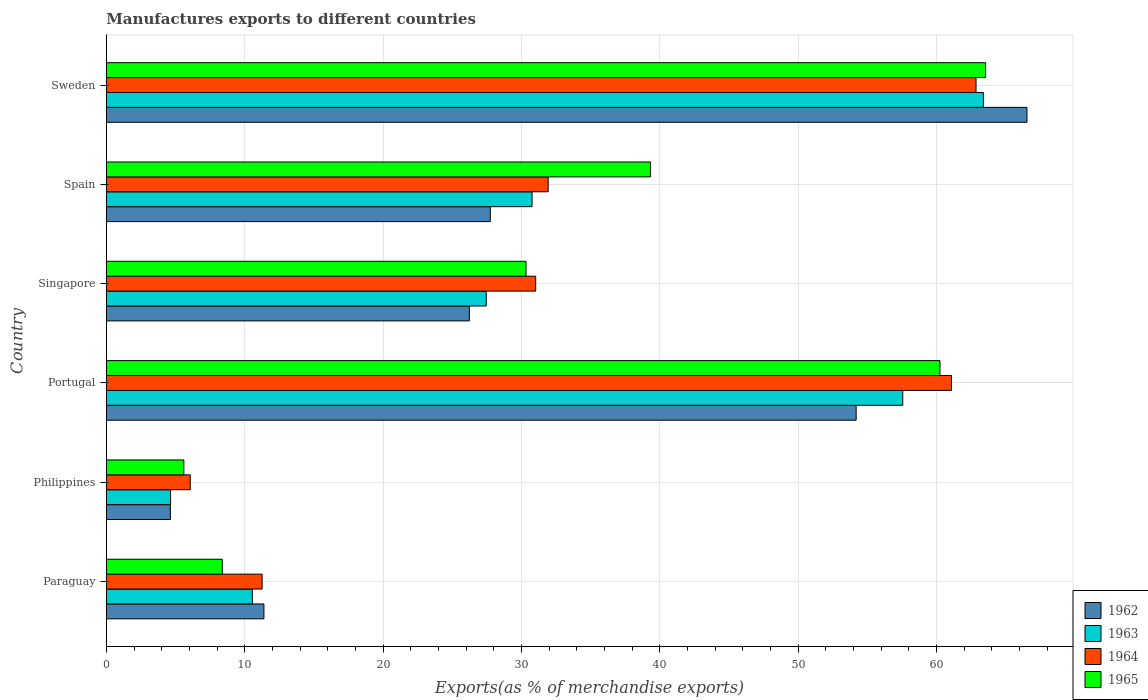How many different coloured bars are there?
Provide a short and direct response. 4. Are the number of bars per tick equal to the number of legend labels?
Offer a terse response. Yes. Are the number of bars on each tick of the Y-axis equal?
Make the answer very short. Yes. How many bars are there on the 1st tick from the bottom?
Make the answer very short. 4. What is the label of the 3rd group of bars from the top?
Provide a succinct answer. Singapore. What is the percentage of exports to different countries in 1965 in Sweden?
Offer a very short reply. 63.55. Across all countries, what is the maximum percentage of exports to different countries in 1964?
Give a very brief answer. 62.86. Across all countries, what is the minimum percentage of exports to different countries in 1964?
Offer a terse response. 6.07. What is the total percentage of exports to different countries in 1962 in the graph?
Keep it short and to the point. 190.73. What is the difference between the percentage of exports to different countries in 1963 in Portugal and that in Singapore?
Keep it short and to the point. 30.1. What is the difference between the percentage of exports to different countries in 1965 in Portugal and the percentage of exports to different countries in 1963 in Paraguay?
Make the answer very short. 49.7. What is the average percentage of exports to different countries in 1964 per country?
Provide a succinct answer. 34.04. What is the difference between the percentage of exports to different countries in 1964 and percentage of exports to different countries in 1965 in Portugal?
Keep it short and to the point. 0.83. What is the ratio of the percentage of exports to different countries in 1964 in Philippines to that in Sweden?
Provide a succinct answer. 0.1. Is the percentage of exports to different countries in 1963 in Singapore less than that in Spain?
Ensure brevity in your answer.  Yes. Is the difference between the percentage of exports to different countries in 1964 in Paraguay and Sweden greater than the difference between the percentage of exports to different countries in 1965 in Paraguay and Sweden?
Your response must be concise. Yes. What is the difference between the highest and the second highest percentage of exports to different countries in 1963?
Your response must be concise. 5.83. What is the difference between the highest and the lowest percentage of exports to different countries in 1963?
Ensure brevity in your answer.  58.74. Is it the case that in every country, the sum of the percentage of exports to different countries in 1962 and percentage of exports to different countries in 1963 is greater than the sum of percentage of exports to different countries in 1964 and percentage of exports to different countries in 1965?
Your answer should be compact. No. What does the 4th bar from the top in Spain represents?
Offer a very short reply. 1962. How many bars are there?
Make the answer very short. 24. Are all the bars in the graph horizontal?
Give a very brief answer. Yes. How many countries are there in the graph?
Your answer should be compact. 6. Does the graph contain any zero values?
Offer a terse response. No. What is the title of the graph?
Ensure brevity in your answer.  Manufactures exports to different countries. What is the label or title of the X-axis?
Offer a very short reply. Exports(as % of merchandise exports). What is the Exports(as % of merchandise exports) in 1962 in Paraguay?
Keep it short and to the point. 11.39. What is the Exports(as % of merchandise exports) of 1963 in Paraguay?
Keep it short and to the point. 10.55. What is the Exports(as % of merchandise exports) in 1964 in Paraguay?
Ensure brevity in your answer.  11.26. What is the Exports(as % of merchandise exports) of 1965 in Paraguay?
Keep it short and to the point. 8.38. What is the Exports(as % of merchandise exports) of 1962 in Philippines?
Provide a short and direct response. 4.63. What is the Exports(as % of merchandise exports) in 1963 in Philippines?
Your response must be concise. 4.64. What is the Exports(as % of merchandise exports) in 1964 in Philippines?
Your response must be concise. 6.07. What is the Exports(as % of merchandise exports) in 1965 in Philippines?
Your answer should be very brief. 5.6. What is the Exports(as % of merchandise exports) in 1962 in Portugal?
Offer a terse response. 54.19. What is the Exports(as % of merchandise exports) of 1963 in Portugal?
Give a very brief answer. 57.56. What is the Exports(as % of merchandise exports) in 1964 in Portugal?
Make the answer very short. 61.08. What is the Exports(as % of merchandise exports) in 1965 in Portugal?
Provide a succinct answer. 60.25. What is the Exports(as % of merchandise exports) in 1962 in Singapore?
Ensure brevity in your answer.  26.24. What is the Exports(as % of merchandise exports) of 1963 in Singapore?
Your answer should be very brief. 27.46. What is the Exports(as % of merchandise exports) of 1964 in Singapore?
Provide a succinct answer. 31.03. What is the Exports(as % of merchandise exports) in 1965 in Singapore?
Make the answer very short. 30.33. What is the Exports(as % of merchandise exports) of 1962 in Spain?
Provide a short and direct response. 27.75. What is the Exports(as % of merchandise exports) of 1963 in Spain?
Offer a very short reply. 30.77. What is the Exports(as % of merchandise exports) of 1964 in Spain?
Make the answer very short. 31.93. What is the Exports(as % of merchandise exports) in 1965 in Spain?
Offer a terse response. 39.33. What is the Exports(as % of merchandise exports) in 1962 in Sweden?
Offer a very short reply. 66.54. What is the Exports(as % of merchandise exports) in 1963 in Sweden?
Make the answer very short. 63.39. What is the Exports(as % of merchandise exports) of 1964 in Sweden?
Provide a succinct answer. 62.86. What is the Exports(as % of merchandise exports) of 1965 in Sweden?
Provide a short and direct response. 63.55. Across all countries, what is the maximum Exports(as % of merchandise exports) in 1962?
Your response must be concise. 66.54. Across all countries, what is the maximum Exports(as % of merchandise exports) of 1963?
Ensure brevity in your answer.  63.39. Across all countries, what is the maximum Exports(as % of merchandise exports) in 1964?
Offer a very short reply. 62.86. Across all countries, what is the maximum Exports(as % of merchandise exports) in 1965?
Offer a terse response. 63.55. Across all countries, what is the minimum Exports(as % of merchandise exports) in 1962?
Ensure brevity in your answer.  4.63. Across all countries, what is the minimum Exports(as % of merchandise exports) of 1963?
Your answer should be very brief. 4.64. Across all countries, what is the minimum Exports(as % of merchandise exports) of 1964?
Provide a short and direct response. 6.07. Across all countries, what is the minimum Exports(as % of merchandise exports) of 1965?
Keep it short and to the point. 5.6. What is the total Exports(as % of merchandise exports) of 1962 in the graph?
Make the answer very short. 190.73. What is the total Exports(as % of merchandise exports) in 1963 in the graph?
Your answer should be compact. 194.38. What is the total Exports(as % of merchandise exports) of 1964 in the graph?
Give a very brief answer. 204.23. What is the total Exports(as % of merchandise exports) in 1965 in the graph?
Your answer should be very brief. 207.45. What is the difference between the Exports(as % of merchandise exports) of 1962 in Paraguay and that in Philippines?
Your response must be concise. 6.76. What is the difference between the Exports(as % of merchandise exports) of 1963 in Paraguay and that in Philippines?
Your answer should be compact. 5.91. What is the difference between the Exports(as % of merchandise exports) in 1964 in Paraguay and that in Philippines?
Offer a very short reply. 5.19. What is the difference between the Exports(as % of merchandise exports) of 1965 in Paraguay and that in Philippines?
Your answer should be very brief. 2.78. What is the difference between the Exports(as % of merchandise exports) in 1962 in Paraguay and that in Portugal?
Keep it short and to the point. -42.8. What is the difference between the Exports(as % of merchandise exports) of 1963 in Paraguay and that in Portugal?
Offer a terse response. -47.01. What is the difference between the Exports(as % of merchandise exports) of 1964 in Paraguay and that in Portugal?
Provide a succinct answer. -49.82. What is the difference between the Exports(as % of merchandise exports) of 1965 in Paraguay and that in Portugal?
Give a very brief answer. -51.87. What is the difference between the Exports(as % of merchandise exports) of 1962 in Paraguay and that in Singapore?
Your answer should be very brief. -14.85. What is the difference between the Exports(as % of merchandise exports) of 1963 in Paraguay and that in Singapore?
Make the answer very short. -16.91. What is the difference between the Exports(as % of merchandise exports) in 1964 in Paraguay and that in Singapore?
Provide a succinct answer. -19.77. What is the difference between the Exports(as % of merchandise exports) of 1965 in Paraguay and that in Singapore?
Provide a short and direct response. -21.95. What is the difference between the Exports(as % of merchandise exports) in 1962 in Paraguay and that in Spain?
Ensure brevity in your answer.  -16.36. What is the difference between the Exports(as % of merchandise exports) in 1963 in Paraguay and that in Spain?
Offer a terse response. -20.22. What is the difference between the Exports(as % of merchandise exports) of 1964 in Paraguay and that in Spain?
Keep it short and to the point. -20.67. What is the difference between the Exports(as % of merchandise exports) of 1965 in Paraguay and that in Spain?
Your answer should be very brief. -30.95. What is the difference between the Exports(as % of merchandise exports) in 1962 in Paraguay and that in Sweden?
Your answer should be compact. -55.15. What is the difference between the Exports(as % of merchandise exports) of 1963 in Paraguay and that in Sweden?
Make the answer very short. -52.83. What is the difference between the Exports(as % of merchandise exports) in 1964 in Paraguay and that in Sweden?
Provide a short and direct response. -51.6. What is the difference between the Exports(as % of merchandise exports) in 1965 in Paraguay and that in Sweden?
Your response must be concise. -55.17. What is the difference between the Exports(as % of merchandise exports) in 1962 in Philippines and that in Portugal?
Keep it short and to the point. -49.57. What is the difference between the Exports(as % of merchandise exports) in 1963 in Philippines and that in Portugal?
Make the answer very short. -52.92. What is the difference between the Exports(as % of merchandise exports) of 1964 in Philippines and that in Portugal?
Keep it short and to the point. -55.02. What is the difference between the Exports(as % of merchandise exports) of 1965 in Philippines and that in Portugal?
Give a very brief answer. -54.65. What is the difference between the Exports(as % of merchandise exports) in 1962 in Philippines and that in Singapore?
Provide a short and direct response. -21.61. What is the difference between the Exports(as % of merchandise exports) of 1963 in Philippines and that in Singapore?
Give a very brief answer. -22.82. What is the difference between the Exports(as % of merchandise exports) in 1964 in Philippines and that in Singapore?
Provide a succinct answer. -24.96. What is the difference between the Exports(as % of merchandise exports) in 1965 in Philippines and that in Singapore?
Your answer should be compact. -24.73. What is the difference between the Exports(as % of merchandise exports) in 1962 in Philippines and that in Spain?
Make the answer very short. -23.12. What is the difference between the Exports(as % of merchandise exports) in 1963 in Philippines and that in Spain?
Make the answer very short. -26.13. What is the difference between the Exports(as % of merchandise exports) of 1964 in Philippines and that in Spain?
Give a very brief answer. -25.87. What is the difference between the Exports(as % of merchandise exports) in 1965 in Philippines and that in Spain?
Your answer should be compact. -33.73. What is the difference between the Exports(as % of merchandise exports) in 1962 in Philippines and that in Sweden?
Ensure brevity in your answer.  -61.91. What is the difference between the Exports(as % of merchandise exports) of 1963 in Philippines and that in Sweden?
Give a very brief answer. -58.74. What is the difference between the Exports(as % of merchandise exports) in 1964 in Philippines and that in Sweden?
Offer a very short reply. -56.79. What is the difference between the Exports(as % of merchandise exports) in 1965 in Philippines and that in Sweden?
Your answer should be very brief. -57.95. What is the difference between the Exports(as % of merchandise exports) in 1962 in Portugal and that in Singapore?
Make the answer very short. 27.96. What is the difference between the Exports(as % of merchandise exports) in 1963 in Portugal and that in Singapore?
Provide a succinct answer. 30.1. What is the difference between the Exports(as % of merchandise exports) in 1964 in Portugal and that in Singapore?
Provide a succinct answer. 30.05. What is the difference between the Exports(as % of merchandise exports) of 1965 in Portugal and that in Singapore?
Ensure brevity in your answer.  29.92. What is the difference between the Exports(as % of merchandise exports) in 1962 in Portugal and that in Spain?
Offer a terse response. 26.44. What is the difference between the Exports(as % of merchandise exports) in 1963 in Portugal and that in Spain?
Offer a very short reply. 26.79. What is the difference between the Exports(as % of merchandise exports) in 1964 in Portugal and that in Spain?
Provide a succinct answer. 29.15. What is the difference between the Exports(as % of merchandise exports) of 1965 in Portugal and that in Spain?
Your answer should be compact. 20.92. What is the difference between the Exports(as % of merchandise exports) in 1962 in Portugal and that in Sweden?
Provide a short and direct response. -12.35. What is the difference between the Exports(as % of merchandise exports) of 1963 in Portugal and that in Sweden?
Give a very brief answer. -5.83. What is the difference between the Exports(as % of merchandise exports) in 1964 in Portugal and that in Sweden?
Offer a terse response. -1.77. What is the difference between the Exports(as % of merchandise exports) in 1965 in Portugal and that in Sweden?
Provide a short and direct response. -3.3. What is the difference between the Exports(as % of merchandise exports) in 1962 in Singapore and that in Spain?
Offer a very short reply. -1.51. What is the difference between the Exports(as % of merchandise exports) of 1963 in Singapore and that in Spain?
Provide a succinct answer. -3.31. What is the difference between the Exports(as % of merchandise exports) in 1964 in Singapore and that in Spain?
Give a very brief answer. -0.9. What is the difference between the Exports(as % of merchandise exports) in 1965 in Singapore and that in Spain?
Offer a terse response. -9. What is the difference between the Exports(as % of merchandise exports) of 1962 in Singapore and that in Sweden?
Make the answer very short. -40.3. What is the difference between the Exports(as % of merchandise exports) of 1963 in Singapore and that in Sweden?
Offer a terse response. -35.93. What is the difference between the Exports(as % of merchandise exports) in 1964 in Singapore and that in Sweden?
Your answer should be compact. -31.83. What is the difference between the Exports(as % of merchandise exports) in 1965 in Singapore and that in Sweden?
Offer a terse response. -33.22. What is the difference between the Exports(as % of merchandise exports) of 1962 in Spain and that in Sweden?
Make the answer very short. -38.79. What is the difference between the Exports(as % of merchandise exports) of 1963 in Spain and that in Sweden?
Provide a succinct answer. -32.62. What is the difference between the Exports(as % of merchandise exports) in 1964 in Spain and that in Sweden?
Keep it short and to the point. -30.92. What is the difference between the Exports(as % of merchandise exports) of 1965 in Spain and that in Sweden?
Offer a terse response. -24.22. What is the difference between the Exports(as % of merchandise exports) in 1962 in Paraguay and the Exports(as % of merchandise exports) in 1963 in Philippines?
Ensure brevity in your answer.  6.75. What is the difference between the Exports(as % of merchandise exports) in 1962 in Paraguay and the Exports(as % of merchandise exports) in 1964 in Philippines?
Your answer should be compact. 5.32. What is the difference between the Exports(as % of merchandise exports) in 1962 in Paraguay and the Exports(as % of merchandise exports) in 1965 in Philippines?
Give a very brief answer. 5.79. What is the difference between the Exports(as % of merchandise exports) of 1963 in Paraguay and the Exports(as % of merchandise exports) of 1964 in Philippines?
Your answer should be compact. 4.49. What is the difference between the Exports(as % of merchandise exports) in 1963 in Paraguay and the Exports(as % of merchandise exports) in 1965 in Philippines?
Keep it short and to the point. 4.95. What is the difference between the Exports(as % of merchandise exports) in 1964 in Paraguay and the Exports(as % of merchandise exports) in 1965 in Philippines?
Your response must be concise. 5.66. What is the difference between the Exports(as % of merchandise exports) of 1962 in Paraguay and the Exports(as % of merchandise exports) of 1963 in Portugal?
Give a very brief answer. -46.17. What is the difference between the Exports(as % of merchandise exports) of 1962 in Paraguay and the Exports(as % of merchandise exports) of 1964 in Portugal?
Provide a short and direct response. -49.69. What is the difference between the Exports(as % of merchandise exports) in 1962 in Paraguay and the Exports(as % of merchandise exports) in 1965 in Portugal?
Your answer should be compact. -48.86. What is the difference between the Exports(as % of merchandise exports) in 1963 in Paraguay and the Exports(as % of merchandise exports) in 1964 in Portugal?
Keep it short and to the point. -50.53. What is the difference between the Exports(as % of merchandise exports) in 1963 in Paraguay and the Exports(as % of merchandise exports) in 1965 in Portugal?
Give a very brief answer. -49.7. What is the difference between the Exports(as % of merchandise exports) in 1964 in Paraguay and the Exports(as % of merchandise exports) in 1965 in Portugal?
Offer a very short reply. -48.99. What is the difference between the Exports(as % of merchandise exports) of 1962 in Paraguay and the Exports(as % of merchandise exports) of 1963 in Singapore?
Your response must be concise. -16.07. What is the difference between the Exports(as % of merchandise exports) of 1962 in Paraguay and the Exports(as % of merchandise exports) of 1964 in Singapore?
Provide a short and direct response. -19.64. What is the difference between the Exports(as % of merchandise exports) in 1962 in Paraguay and the Exports(as % of merchandise exports) in 1965 in Singapore?
Make the answer very short. -18.94. What is the difference between the Exports(as % of merchandise exports) in 1963 in Paraguay and the Exports(as % of merchandise exports) in 1964 in Singapore?
Your answer should be compact. -20.48. What is the difference between the Exports(as % of merchandise exports) in 1963 in Paraguay and the Exports(as % of merchandise exports) in 1965 in Singapore?
Give a very brief answer. -19.78. What is the difference between the Exports(as % of merchandise exports) of 1964 in Paraguay and the Exports(as % of merchandise exports) of 1965 in Singapore?
Offer a terse response. -19.07. What is the difference between the Exports(as % of merchandise exports) of 1962 in Paraguay and the Exports(as % of merchandise exports) of 1963 in Spain?
Ensure brevity in your answer.  -19.38. What is the difference between the Exports(as % of merchandise exports) in 1962 in Paraguay and the Exports(as % of merchandise exports) in 1964 in Spain?
Provide a short and direct response. -20.54. What is the difference between the Exports(as % of merchandise exports) in 1962 in Paraguay and the Exports(as % of merchandise exports) in 1965 in Spain?
Your response must be concise. -27.94. What is the difference between the Exports(as % of merchandise exports) in 1963 in Paraguay and the Exports(as % of merchandise exports) in 1964 in Spain?
Give a very brief answer. -21.38. What is the difference between the Exports(as % of merchandise exports) of 1963 in Paraguay and the Exports(as % of merchandise exports) of 1965 in Spain?
Keep it short and to the point. -28.78. What is the difference between the Exports(as % of merchandise exports) of 1964 in Paraguay and the Exports(as % of merchandise exports) of 1965 in Spain?
Your answer should be very brief. -28.07. What is the difference between the Exports(as % of merchandise exports) of 1962 in Paraguay and the Exports(as % of merchandise exports) of 1963 in Sweden?
Provide a short and direct response. -52. What is the difference between the Exports(as % of merchandise exports) of 1962 in Paraguay and the Exports(as % of merchandise exports) of 1964 in Sweden?
Ensure brevity in your answer.  -51.47. What is the difference between the Exports(as % of merchandise exports) of 1962 in Paraguay and the Exports(as % of merchandise exports) of 1965 in Sweden?
Your answer should be compact. -52.16. What is the difference between the Exports(as % of merchandise exports) in 1963 in Paraguay and the Exports(as % of merchandise exports) in 1964 in Sweden?
Your answer should be very brief. -52.3. What is the difference between the Exports(as % of merchandise exports) of 1963 in Paraguay and the Exports(as % of merchandise exports) of 1965 in Sweden?
Your answer should be compact. -52.99. What is the difference between the Exports(as % of merchandise exports) of 1964 in Paraguay and the Exports(as % of merchandise exports) of 1965 in Sweden?
Give a very brief answer. -52.29. What is the difference between the Exports(as % of merchandise exports) of 1962 in Philippines and the Exports(as % of merchandise exports) of 1963 in Portugal?
Keep it short and to the point. -52.93. What is the difference between the Exports(as % of merchandise exports) of 1962 in Philippines and the Exports(as % of merchandise exports) of 1964 in Portugal?
Give a very brief answer. -56.46. What is the difference between the Exports(as % of merchandise exports) in 1962 in Philippines and the Exports(as % of merchandise exports) in 1965 in Portugal?
Provide a short and direct response. -55.62. What is the difference between the Exports(as % of merchandise exports) of 1963 in Philippines and the Exports(as % of merchandise exports) of 1964 in Portugal?
Ensure brevity in your answer.  -56.44. What is the difference between the Exports(as % of merchandise exports) in 1963 in Philippines and the Exports(as % of merchandise exports) in 1965 in Portugal?
Make the answer very short. -55.61. What is the difference between the Exports(as % of merchandise exports) in 1964 in Philippines and the Exports(as % of merchandise exports) in 1965 in Portugal?
Provide a short and direct response. -54.18. What is the difference between the Exports(as % of merchandise exports) of 1962 in Philippines and the Exports(as % of merchandise exports) of 1963 in Singapore?
Your answer should be compact. -22.83. What is the difference between the Exports(as % of merchandise exports) of 1962 in Philippines and the Exports(as % of merchandise exports) of 1964 in Singapore?
Offer a terse response. -26.4. What is the difference between the Exports(as % of merchandise exports) of 1962 in Philippines and the Exports(as % of merchandise exports) of 1965 in Singapore?
Keep it short and to the point. -25.7. What is the difference between the Exports(as % of merchandise exports) of 1963 in Philippines and the Exports(as % of merchandise exports) of 1964 in Singapore?
Your response must be concise. -26.39. What is the difference between the Exports(as % of merchandise exports) in 1963 in Philippines and the Exports(as % of merchandise exports) in 1965 in Singapore?
Offer a very short reply. -25.69. What is the difference between the Exports(as % of merchandise exports) in 1964 in Philippines and the Exports(as % of merchandise exports) in 1965 in Singapore?
Offer a terse response. -24.27. What is the difference between the Exports(as % of merchandise exports) in 1962 in Philippines and the Exports(as % of merchandise exports) in 1963 in Spain?
Keep it short and to the point. -26.14. What is the difference between the Exports(as % of merchandise exports) in 1962 in Philippines and the Exports(as % of merchandise exports) in 1964 in Spain?
Your answer should be very brief. -27.31. What is the difference between the Exports(as % of merchandise exports) of 1962 in Philippines and the Exports(as % of merchandise exports) of 1965 in Spain?
Provide a short and direct response. -34.71. What is the difference between the Exports(as % of merchandise exports) of 1963 in Philippines and the Exports(as % of merchandise exports) of 1964 in Spain?
Your answer should be very brief. -27.29. What is the difference between the Exports(as % of merchandise exports) in 1963 in Philippines and the Exports(as % of merchandise exports) in 1965 in Spain?
Your response must be concise. -34.69. What is the difference between the Exports(as % of merchandise exports) in 1964 in Philippines and the Exports(as % of merchandise exports) in 1965 in Spain?
Your answer should be very brief. -33.27. What is the difference between the Exports(as % of merchandise exports) in 1962 in Philippines and the Exports(as % of merchandise exports) in 1963 in Sweden?
Give a very brief answer. -58.76. What is the difference between the Exports(as % of merchandise exports) of 1962 in Philippines and the Exports(as % of merchandise exports) of 1964 in Sweden?
Provide a short and direct response. -58.23. What is the difference between the Exports(as % of merchandise exports) in 1962 in Philippines and the Exports(as % of merchandise exports) in 1965 in Sweden?
Provide a short and direct response. -58.92. What is the difference between the Exports(as % of merchandise exports) in 1963 in Philippines and the Exports(as % of merchandise exports) in 1964 in Sweden?
Ensure brevity in your answer.  -58.21. What is the difference between the Exports(as % of merchandise exports) of 1963 in Philippines and the Exports(as % of merchandise exports) of 1965 in Sweden?
Ensure brevity in your answer.  -58.91. What is the difference between the Exports(as % of merchandise exports) of 1964 in Philippines and the Exports(as % of merchandise exports) of 1965 in Sweden?
Give a very brief answer. -57.48. What is the difference between the Exports(as % of merchandise exports) of 1962 in Portugal and the Exports(as % of merchandise exports) of 1963 in Singapore?
Keep it short and to the point. 26.73. What is the difference between the Exports(as % of merchandise exports) in 1962 in Portugal and the Exports(as % of merchandise exports) in 1964 in Singapore?
Give a very brief answer. 23.16. What is the difference between the Exports(as % of merchandise exports) of 1962 in Portugal and the Exports(as % of merchandise exports) of 1965 in Singapore?
Your answer should be very brief. 23.86. What is the difference between the Exports(as % of merchandise exports) in 1963 in Portugal and the Exports(as % of merchandise exports) in 1964 in Singapore?
Give a very brief answer. 26.53. What is the difference between the Exports(as % of merchandise exports) in 1963 in Portugal and the Exports(as % of merchandise exports) in 1965 in Singapore?
Ensure brevity in your answer.  27.23. What is the difference between the Exports(as % of merchandise exports) in 1964 in Portugal and the Exports(as % of merchandise exports) in 1965 in Singapore?
Your response must be concise. 30.75. What is the difference between the Exports(as % of merchandise exports) in 1962 in Portugal and the Exports(as % of merchandise exports) in 1963 in Spain?
Your answer should be compact. 23.42. What is the difference between the Exports(as % of merchandise exports) of 1962 in Portugal and the Exports(as % of merchandise exports) of 1964 in Spain?
Offer a terse response. 22.26. What is the difference between the Exports(as % of merchandise exports) of 1962 in Portugal and the Exports(as % of merchandise exports) of 1965 in Spain?
Keep it short and to the point. 14.86. What is the difference between the Exports(as % of merchandise exports) of 1963 in Portugal and the Exports(as % of merchandise exports) of 1964 in Spain?
Your answer should be compact. 25.63. What is the difference between the Exports(as % of merchandise exports) of 1963 in Portugal and the Exports(as % of merchandise exports) of 1965 in Spain?
Offer a terse response. 18.23. What is the difference between the Exports(as % of merchandise exports) of 1964 in Portugal and the Exports(as % of merchandise exports) of 1965 in Spain?
Provide a short and direct response. 21.75. What is the difference between the Exports(as % of merchandise exports) of 1962 in Portugal and the Exports(as % of merchandise exports) of 1963 in Sweden?
Give a very brief answer. -9.2. What is the difference between the Exports(as % of merchandise exports) of 1962 in Portugal and the Exports(as % of merchandise exports) of 1964 in Sweden?
Ensure brevity in your answer.  -8.66. What is the difference between the Exports(as % of merchandise exports) in 1962 in Portugal and the Exports(as % of merchandise exports) in 1965 in Sweden?
Provide a short and direct response. -9.36. What is the difference between the Exports(as % of merchandise exports) of 1963 in Portugal and the Exports(as % of merchandise exports) of 1964 in Sweden?
Provide a short and direct response. -5.3. What is the difference between the Exports(as % of merchandise exports) in 1963 in Portugal and the Exports(as % of merchandise exports) in 1965 in Sweden?
Offer a terse response. -5.99. What is the difference between the Exports(as % of merchandise exports) of 1964 in Portugal and the Exports(as % of merchandise exports) of 1965 in Sweden?
Offer a terse response. -2.47. What is the difference between the Exports(as % of merchandise exports) in 1962 in Singapore and the Exports(as % of merchandise exports) in 1963 in Spain?
Your answer should be compact. -4.53. What is the difference between the Exports(as % of merchandise exports) of 1962 in Singapore and the Exports(as % of merchandise exports) of 1964 in Spain?
Provide a succinct answer. -5.7. What is the difference between the Exports(as % of merchandise exports) of 1962 in Singapore and the Exports(as % of merchandise exports) of 1965 in Spain?
Ensure brevity in your answer.  -13.1. What is the difference between the Exports(as % of merchandise exports) of 1963 in Singapore and the Exports(as % of merchandise exports) of 1964 in Spain?
Keep it short and to the point. -4.47. What is the difference between the Exports(as % of merchandise exports) of 1963 in Singapore and the Exports(as % of merchandise exports) of 1965 in Spain?
Make the answer very short. -11.87. What is the difference between the Exports(as % of merchandise exports) in 1964 in Singapore and the Exports(as % of merchandise exports) in 1965 in Spain?
Ensure brevity in your answer.  -8.3. What is the difference between the Exports(as % of merchandise exports) of 1962 in Singapore and the Exports(as % of merchandise exports) of 1963 in Sweden?
Your answer should be very brief. -37.15. What is the difference between the Exports(as % of merchandise exports) of 1962 in Singapore and the Exports(as % of merchandise exports) of 1964 in Sweden?
Offer a very short reply. -36.62. What is the difference between the Exports(as % of merchandise exports) of 1962 in Singapore and the Exports(as % of merchandise exports) of 1965 in Sweden?
Give a very brief answer. -37.31. What is the difference between the Exports(as % of merchandise exports) in 1963 in Singapore and the Exports(as % of merchandise exports) in 1964 in Sweden?
Provide a short and direct response. -35.4. What is the difference between the Exports(as % of merchandise exports) in 1963 in Singapore and the Exports(as % of merchandise exports) in 1965 in Sweden?
Offer a very short reply. -36.09. What is the difference between the Exports(as % of merchandise exports) of 1964 in Singapore and the Exports(as % of merchandise exports) of 1965 in Sweden?
Offer a very short reply. -32.52. What is the difference between the Exports(as % of merchandise exports) in 1962 in Spain and the Exports(as % of merchandise exports) in 1963 in Sweden?
Give a very brief answer. -35.64. What is the difference between the Exports(as % of merchandise exports) of 1962 in Spain and the Exports(as % of merchandise exports) of 1964 in Sweden?
Offer a terse response. -35.11. What is the difference between the Exports(as % of merchandise exports) of 1962 in Spain and the Exports(as % of merchandise exports) of 1965 in Sweden?
Give a very brief answer. -35.8. What is the difference between the Exports(as % of merchandise exports) of 1963 in Spain and the Exports(as % of merchandise exports) of 1964 in Sweden?
Provide a short and direct response. -32.09. What is the difference between the Exports(as % of merchandise exports) in 1963 in Spain and the Exports(as % of merchandise exports) in 1965 in Sweden?
Offer a very short reply. -32.78. What is the difference between the Exports(as % of merchandise exports) in 1964 in Spain and the Exports(as % of merchandise exports) in 1965 in Sweden?
Your response must be concise. -31.62. What is the average Exports(as % of merchandise exports) in 1962 per country?
Offer a terse response. 31.79. What is the average Exports(as % of merchandise exports) of 1963 per country?
Ensure brevity in your answer.  32.4. What is the average Exports(as % of merchandise exports) in 1964 per country?
Keep it short and to the point. 34.04. What is the average Exports(as % of merchandise exports) in 1965 per country?
Make the answer very short. 34.57. What is the difference between the Exports(as % of merchandise exports) in 1962 and Exports(as % of merchandise exports) in 1963 in Paraguay?
Your answer should be very brief. 0.83. What is the difference between the Exports(as % of merchandise exports) of 1962 and Exports(as % of merchandise exports) of 1964 in Paraguay?
Provide a short and direct response. 0.13. What is the difference between the Exports(as % of merchandise exports) in 1962 and Exports(as % of merchandise exports) in 1965 in Paraguay?
Give a very brief answer. 3.01. What is the difference between the Exports(as % of merchandise exports) of 1963 and Exports(as % of merchandise exports) of 1964 in Paraguay?
Keep it short and to the point. -0.71. What is the difference between the Exports(as % of merchandise exports) in 1963 and Exports(as % of merchandise exports) in 1965 in Paraguay?
Your response must be concise. 2.17. What is the difference between the Exports(as % of merchandise exports) of 1964 and Exports(as % of merchandise exports) of 1965 in Paraguay?
Ensure brevity in your answer.  2.88. What is the difference between the Exports(as % of merchandise exports) in 1962 and Exports(as % of merchandise exports) in 1963 in Philippines?
Your answer should be compact. -0.02. What is the difference between the Exports(as % of merchandise exports) in 1962 and Exports(as % of merchandise exports) in 1964 in Philippines?
Provide a short and direct response. -1.44. What is the difference between the Exports(as % of merchandise exports) of 1962 and Exports(as % of merchandise exports) of 1965 in Philippines?
Give a very brief answer. -0.98. What is the difference between the Exports(as % of merchandise exports) in 1963 and Exports(as % of merchandise exports) in 1964 in Philippines?
Offer a very short reply. -1.42. What is the difference between the Exports(as % of merchandise exports) in 1963 and Exports(as % of merchandise exports) in 1965 in Philippines?
Offer a very short reply. -0.96. What is the difference between the Exports(as % of merchandise exports) of 1964 and Exports(as % of merchandise exports) of 1965 in Philippines?
Provide a short and direct response. 0.46. What is the difference between the Exports(as % of merchandise exports) of 1962 and Exports(as % of merchandise exports) of 1963 in Portugal?
Offer a very short reply. -3.37. What is the difference between the Exports(as % of merchandise exports) of 1962 and Exports(as % of merchandise exports) of 1964 in Portugal?
Provide a short and direct response. -6.89. What is the difference between the Exports(as % of merchandise exports) of 1962 and Exports(as % of merchandise exports) of 1965 in Portugal?
Your answer should be compact. -6.06. What is the difference between the Exports(as % of merchandise exports) of 1963 and Exports(as % of merchandise exports) of 1964 in Portugal?
Provide a short and direct response. -3.52. What is the difference between the Exports(as % of merchandise exports) in 1963 and Exports(as % of merchandise exports) in 1965 in Portugal?
Make the answer very short. -2.69. What is the difference between the Exports(as % of merchandise exports) of 1964 and Exports(as % of merchandise exports) of 1965 in Portugal?
Your response must be concise. 0.83. What is the difference between the Exports(as % of merchandise exports) in 1962 and Exports(as % of merchandise exports) in 1963 in Singapore?
Make the answer very short. -1.22. What is the difference between the Exports(as % of merchandise exports) of 1962 and Exports(as % of merchandise exports) of 1964 in Singapore?
Give a very brief answer. -4.79. What is the difference between the Exports(as % of merchandise exports) of 1962 and Exports(as % of merchandise exports) of 1965 in Singapore?
Your answer should be very brief. -4.1. What is the difference between the Exports(as % of merchandise exports) of 1963 and Exports(as % of merchandise exports) of 1964 in Singapore?
Your response must be concise. -3.57. What is the difference between the Exports(as % of merchandise exports) in 1963 and Exports(as % of merchandise exports) in 1965 in Singapore?
Provide a succinct answer. -2.87. What is the difference between the Exports(as % of merchandise exports) in 1964 and Exports(as % of merchandise exports) in 1965 in Singapore?
Offer a terse response. 0.7. What is the difference between the Exports(as % of merchandise exports) of 1962 and Exports(as % of merchandise exports) of 1963 in Spain?
Your response must be concise. -3.02. What is the difference between the Exports(as % of merchandise exports) of 1962 and Exports(as % of merchandise exports) of 1964 in Spain?
Your response must be concise. -4.18. What is the difference between the Exports(as % of merchandise exports) of 1962 and Exports(as % of merchandise exports) of 1965 in Spain?
Offer a very short reply. -11.58. What is the difference between the Exports(as % of merchandise exports) in 1963 and Exports(as % of merchandise exports) in 1964 in Spain?
Offer a terse response. -1.16. What is the difference between the Exports(as % of merchandise exports) in 1963 and Exports(as % of merchandise exports) in 1965 in Spain?
Give a very brief answer. -8.56. What is the difference between the Exports(as % of merchandise exports) of 1964 and Exports(as % of merchandise exports) of 1965 in Spain?
Keep it short and to the point. -7.4. What is the difference between the Exports(as % of merchandise exports) in 1962 and Exports(as % of merchandise exports) in 1963 in Sweden?
Offer a very short reply. 3.15. What is the difference between the Exports(as % of merchandise exports) of 1962 and Exports(as % of merchandise exports) of 1964 in Sweden?
Provide a short and direct response. 3.68. What is the difference between the Exports(as % of merchandise exports) in 1962 and Exports(as % of merchandise exports) in 1965 in Sweden?
Offer a terse response. 2.99. What is the difference between the Exports(as % of merchandise exports) in 1963 and Exports(as % of merchandise exports) in 1964 in Sweden?
Provide a short and direct response. 0.53. What is the difference between the Exports(as % of merchandise exports) of 1963 and Exports(as % of merchandise exports) of 1965 in Sweden?
Provide a short and direct response. -0.16. What is the difference between the Exports(as % of merchandise exports) in 1964 and Exports(as % of merchandise exports) in 1965 in Sweden?
Provide a succinct answer. -0.69. What is the ratio of the Exports(as % of merchandise exports) of 1962 in Paraguay to that in Philippines?
Your answer should be compact. 2.46. What is the ratio of the Exports(as % of merchandise exports) of 1963 in Paraguay to that in Philippines?
Give a very brief answer. 2.27. What is the ratio of the Exports(as % of merchandise exports) of 1964 in Paraguay to that in Philippines?
Your response must be concise. 1.86. What is the ratio of the Exports(as % of merchandise exports) of 1965 in Paraguay to that in Philippines?
Offer a very short reply. 1.5. What is the ratio of the Exports(as % of merchandise exports) of 1962 in Paraguay to that in Portugal?
Offer a terse response. 0.21. What is the ratio of the Exports(as % of merchandise exports) in 1963 in Paraguay to that in Portugal?
Give a very brief answer. 0.18. What is the ratio of the Exports(as % of merchandise exports) of 1964 in Paraguay to that in Portugal?
Offer a very short reply. 0.18. What is the ratio of the Exports(as % of merchandise exports) in 1965 in Paraguay to that in Portugal?
Provide a short and direct response. 0.14. What is the ratio of the Exports(as % of merchandise exports) in 1962 in Paraguay to that in Singapore?
Your answer should be very brief. 0.43. What is the ratio of the Exports(as % of merchandise exports) in 1963 in Paraguay to that in Singapore?
Your answer should be very brief. 0.38. What is the ratio of the Exports(as % of merchandise exports) in 1964 in Paraguay to that in Singapore?
Give a very brief answer. 0.36. What is the ratio of the Exports(as % of merchandise exports) in 1965 in Paraguay to that in Singapore?
Your answer should be compact. 0.28. What is the ratio of the Exports(as % of merchandise exports) in 1962 in Paraguay to that in Spain?
Provide a short and direct response. 0.41. What is the ratio of the Exports(as % of merchandise exports) in 1963 in Paraguay to that in Spain?
Your answer should be compact. 0.34. What is the ratio of the Exports(as % of merchandise exports) in 1964 in Paraguay to that in Spain?
Offer a very short reply. 0.35. What is the ratio of the Exports(as % of merchandise exports) in 1965 in Paraguay to that in Spain?
Provide a short and direct response. 0.21. What is the ratio of the Exports(as % of merchandise exports) in 1962 in Paraguay to that in Sweden?
Provide a short and direct response. 0.17. What is the ratio of the Exports(as % of merchandise exports) in 1963 in Paraguay to that in Sweden?
Your response must be concise. 0.17. What is the ratio of the Exports(as % of merchandise exports) in 1964 in Paraguay to that in Sweden?
Your answer should be very brief. 0.18. What is the ratio of the Exports(as % of merchandise exports) in 1965 in Paraguay to that in Sweden?
Ensure brevity in your answer.  0.13. What is the ratio of the Exports(as % of merchandise exports) of 1962 in Philippines to that in Portugal?
Ensure brevity in your answer.  0.09. What is the ratio of the Exports(as % of merchandise exports) of 1963 in Philippines to that in Portugal?
Offer a very short reply. 0.08. What is the ratio of the Exports(as % of merchandise exports) in 1964 in Philippines to that in Portugal?
Offer a very short reply. 0.1. What is the ratio of the Exports(as % of merchandise exports) of 1965 in Philippines to that in Portugal?
Your answer should be very brief. 0.09. What is the ratio of the Exports(as % of merchandise exports) of 1962 in Philippines to that in Singapore?
Your answer should be very brief. 0.18. What is the ratio of the Exports(as % of merchandise exports) in 1963 in Philippines to that in Singapore?
Provide a short and direct response. 0.17. What is the ratio of the Exports(as % of merchandise exports) in 1964 in Philippines to that in Singapore?
Keep it short and to the point. 0.2. What is the ratio of the Exports(as % of merchandise exports) in 1965 in Philippines to that in Singapore?
Your answer should be compact. 0.18. What is the ratio of the Exports(as % of merchandise exports) of 1962 in Philippines to that in Spain?
Give a very brief answer. 0.17. What is the ratio of the Exports(as % of merchandise exports) in 1963 in Philippines to that in Spain?
Ensure brevity in your answer.  0.15. What is the ratio of the Exports(as % of merchandise exports) of 1964 in Philippines to that in Spain?
Offer a terse response. 0.19. What is the ratio of the Exports(as % of merchandise exports) in 1965 in Philippines to that in Spain?
Provide a short and direct response. 0.14. What is the ratio of the Exports(as % of merchandise exports) in 1962 in Philippines to that in Sweden?
Provide a succinct answer. 0.07. What is the ratio of the Exports(as % of merchandise exports) in 1963 in Philippines to that in Sweden?
Your answer should be compact. 0.07. What is the ratio of the Exports(as % of merchandise exports) of 1964 in Philippines to that in Sweden?
Offer a very short reply. 0.1. What is the ratio of the Exports(as % of merchandise exports) in 1965 in Philippines to that in Sweden?
Provide a succinct answer. 0.09. What is the ratio of the Exports(as % of merchandise exports) of 1962 in Portugal to that in Singapore?
Your answer should be compact. 2.07. What is the ratio of the Exports(as % of merchandise exports) in 1963 in Portugal to that in Singapore?
Your answer should be compact. 2.1. What is the ratio of the Exports(as % of merchandise exports) of 1964 in Portugal to that in Singapore?
Your answer should be compact. 1.97. What is the ratio of the Exports(as % of merchandise exports) in 1965 in Portugal to that in Singapore?
Keep it short and to the point. 1.99. What is the ratio of the Exports(as % of merchandise exports) in 1962 in Portugal to that in Spain?
Offer a terse response. 1.95. What is the ratio of the Exports(as % of merchandise exports) in 1963 in Portugal to that in Spain?
Keep it short and to the point. 1.87. What is the ratio of the Exports(as % of merchandise exports) in 1964 in Portugal to that in Spain?
Offer a terse response. 1.91. What is the ratio of the Exports(as % of merchandise exports) in 1965 in Portugal to that in Spain?
Your answer should be very brief. 1.53. What is the ratio of the Exports(as % of merchandise exports) in 1962 in Portugal to that in Sweden?
Offer a terse response. 0.81. What is the ratio of the Exports(as % of merchandise exports) of 1963 in Portugal to that in Sweden?
Your answer should be compact. 0.91. What is the ratio of the Exports(as % of merchandise exports) of 1964 in Portugal to that in Sweden?
Provide a succinct answer. 0.97. What is the ratio of the Exports(as % of merchandise exports) in 1965 in Portugal to that in Sweden?
Offer a terse response. 0.95. What is the ratio of the Exports(as % of merchandise exports) of 1962 in Singapore to that in Spain?
Your answer should be compact. 0.95. What is the ratio of the Exports(as % of merchandise exports) in 1963 in Singapore to that in Spain?
Give a very brief answer. 0.89. What is the ratio of the Exports(as % of merchandise exports) of 1964 in Singapore to that in Spain?
Give a very brief answer. 0.97. What is the ratio of the Exports(as % of merchandise exports) in 1965 in Singapore to that in Spain?
Give a very brief answer. 0.77. What is the ratio of the Exports(as % of merchandise exports) of 1962 in Singapore to that in Sweden?
Offer a terse response. 0.39. What is the ratio of the Exports(as % of merchandise exports) of 1963 in Singapore to that in Sweden?
Provide a short and direct response. 0.43. What is the ratio of the Exports(as % of merchandise exports) in 1964 in Singapore to that in Sweden?
Offer a terse response. 0.49. What is the ratio of the Exports(as % of merchandise exports) in 1965 in Singapore to that in Sweden?
Your answer should be very brief. 0.48. What is the ratio of the Exports(as % of merchandise exports) in 1962 in Spain to that in Sweden?
Ensure brevity in your answer.  0.42. What is the ratio of the Exports(as % of merchandise exports) in 1963 in Spain to that in Sweden?
Offer a very short reply. 0.49. What is the ratio of the Exports(as % of merchandise exports) in 1964 in Spain to that in Sweden?
Provide a short and direct response. 0.51. What is the ratio of the Exports(as % of merchandise exports) in 1965 in Spain to that in Sweden?
Your answer should be compact. 0.62. What is the difference between the highest and the second highest Exports(as % of merchandise exports) of 1962?
Provide a succinct answer. 12.35. What is the difference between the highest and the second highest Exports(as % of merchandise exports) in 1963?
Keep it short and to the point. 5.83. What is the difference between the highest and the second highest Exports(as % of merchandise exports) in 1964?
Ensure brevity in your answer.  1.77. What is the difference between the highest and the second highest Exports(as % of merchandise exports) in 1965?
Provide a succinct answer. 3.3. What is the difference between the highest and the lowest Exports(as % of merchandise exports) of 1962?
Make the answer very short. 61.91. What is the difference between the highest and the lowest Exports(as % of merchandise exports) in 1963?
Make the answer very short. 58.74. What is the difference between the highest and the lowest Exports(as % of merchandise exports) of 1964?
Offer a terse response. 56.79. What is the difference between the highest and the lowest Exports(as % of merchandise exports) of 1965?
Your answer should be compact. 57.95. 